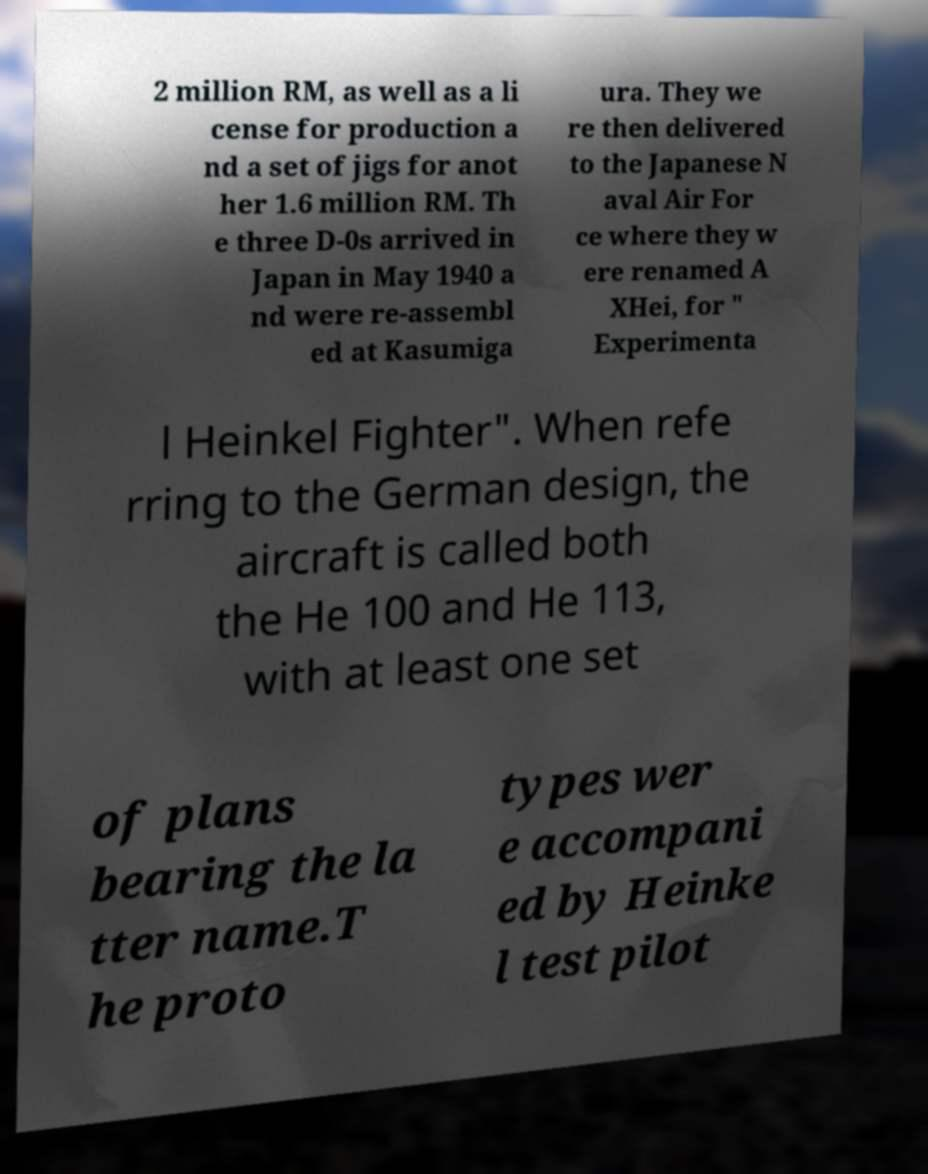I need the written content from this picture converted into text. Can you do that? 2 million RM, as well as a li cense for production a nd a set of jigs for anot her 1.6 million RM. Th e three D-0s arrived in Japan in May 1940 a nd were re-assembl ed at Kasumiga ura. They we re then delivered to the Japanese N aval Air For ce where they w ere renamed A XHei, for " Experimenta l Heinkel Fighter". When refe rring to the German design, the aircraft is called both the He 100 and He 113, with at least one set of plans bearing the la tter name.T he proto types wer e accompani ed by Heinke l test pilot 